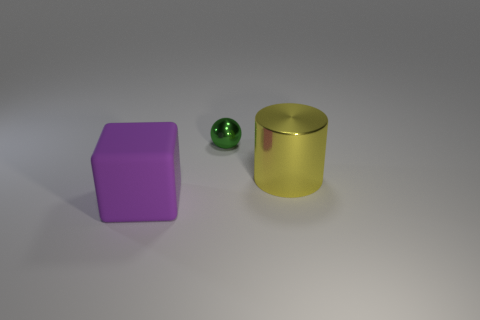Could you describe the lighting and shadows in the image? The shadows fall to the right side of the objects, indicating a light source coming from the left. The lighting seems soft and diffuse, with gentle shadows, suggesting an ambient light source, as there are no harsh or sharply defined shadows. What can you infer about the time of day or setting from the lighting? Since the lighting is artificial and controlled, as evidenced by its softness and lack of natural elements, it's difficult to infer the time of day or specific settings outside of a studio or indoor environment. 